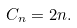Convert formula to latex. <formula><loc_0><loc_0><loc_500><loc_500>C _ { n } = 2 n .</formula> 